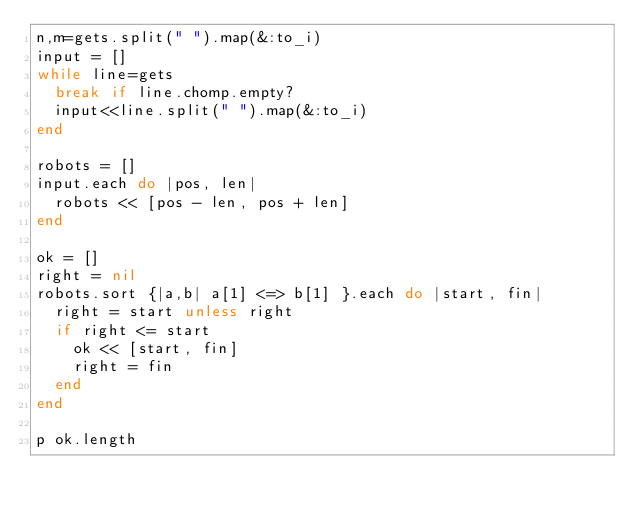Convert code to text. <code><loc_0><loc_0><loc_500><loc_500><_Ruby_>n,m=gets.split(" ").map(&:to_i)
input = []
while line=gets
  break if line.chomp.empty?
  input<<line.split(" ").map(&:to_i)
end

robots = []
input.each do |pos, len|
  robots << [pos - len, pos + len]
end

ok = []
right = nil
robots.sort {|a,b| a[1] <=> b[1] }.each do |start, fin|
  right = start unless right
  if right <= start
    ok << [start, fin]
    right = fin
  end
end

p ok.length</code> 